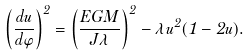Convert formula to latex. <formula><loc_0><loc_0><loc_500><loc_500>\left ( \frac { d u } { d \varphi } \right ) ^ { 2 } = \left ( \frac { E G M } { J \lambda } \right ) ^ { 2 } - \lambda u ^ { 2 } ( 1 - 2 u ) .</formula> 